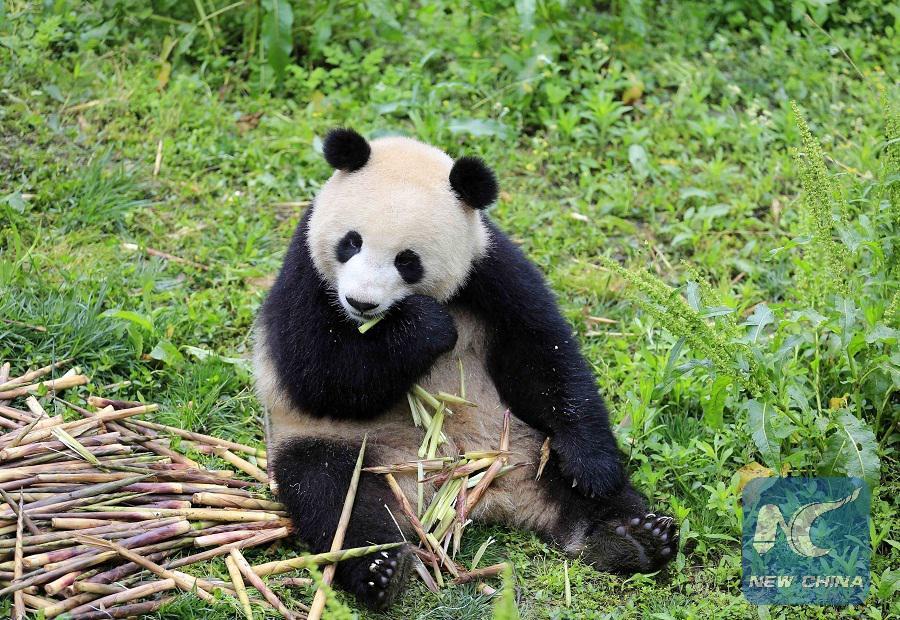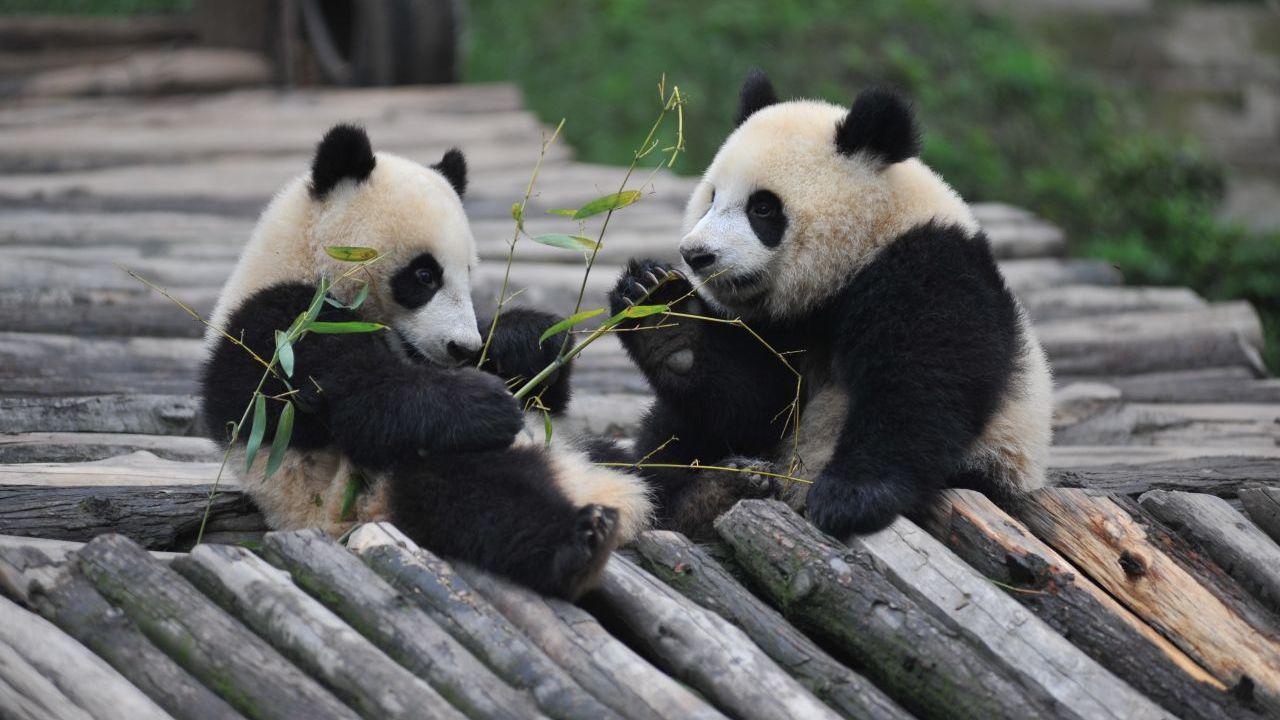The first image is the image on the left, the second image is the image on the right. Assess this claim about the two images: "One image shows pandas sitting side by side, each with a paw raised to its mouth, and the other image shows two pandas who are looking toward one another.". Correct or not? Answer yes or no. No. The first image is the image on the left, the second image is the image on the right. For the images displayed, is the sentence "Both images in the pair have two pandas." factually correct? Answer yes or no. No. 